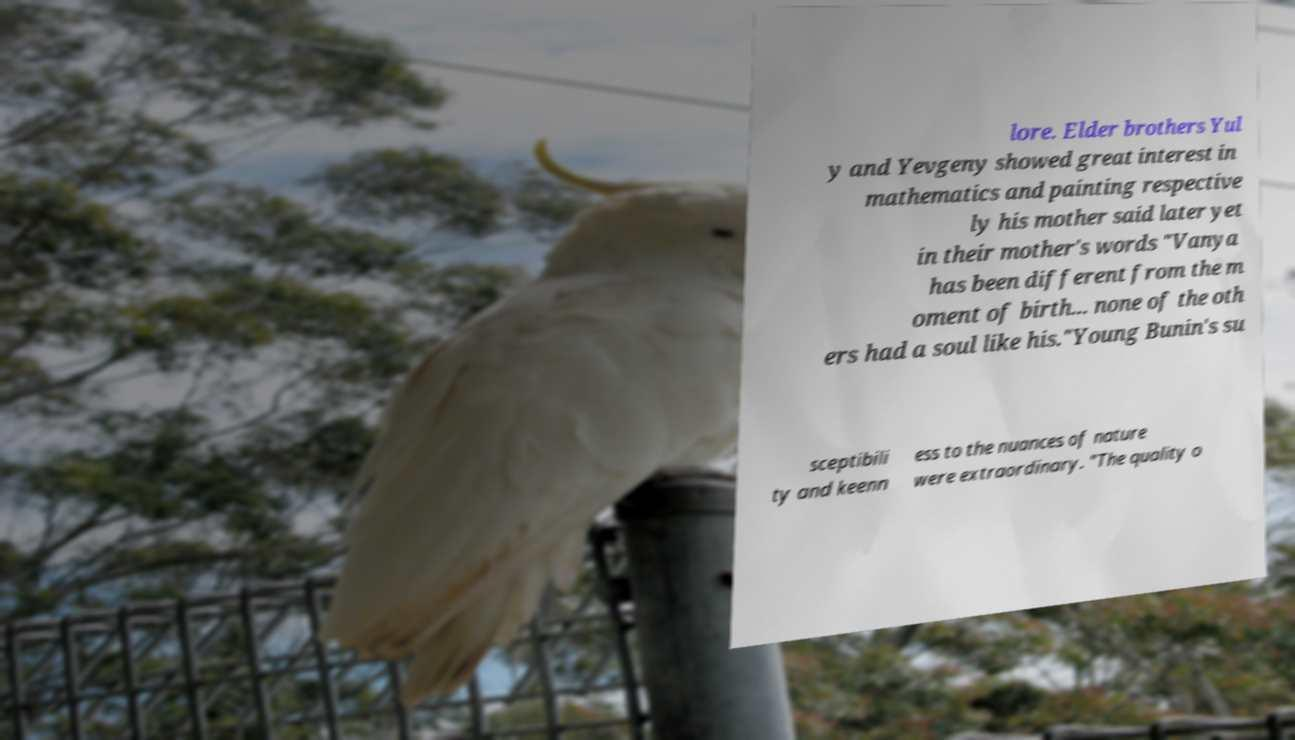Could you assist in decoding the text presented in this image and type it out clearly? lore. Elder brothers Yul y and Yevgeny showed great interest in mathematics and painting respective ly his mother said later yet in their mother's words "Vanya has been different from the m oment of birth... none of the oth ers had a soul like his."Young Bunin's su sceptibili ty and keenn ess to the nuances of nature were extraordinary. "The quality o 